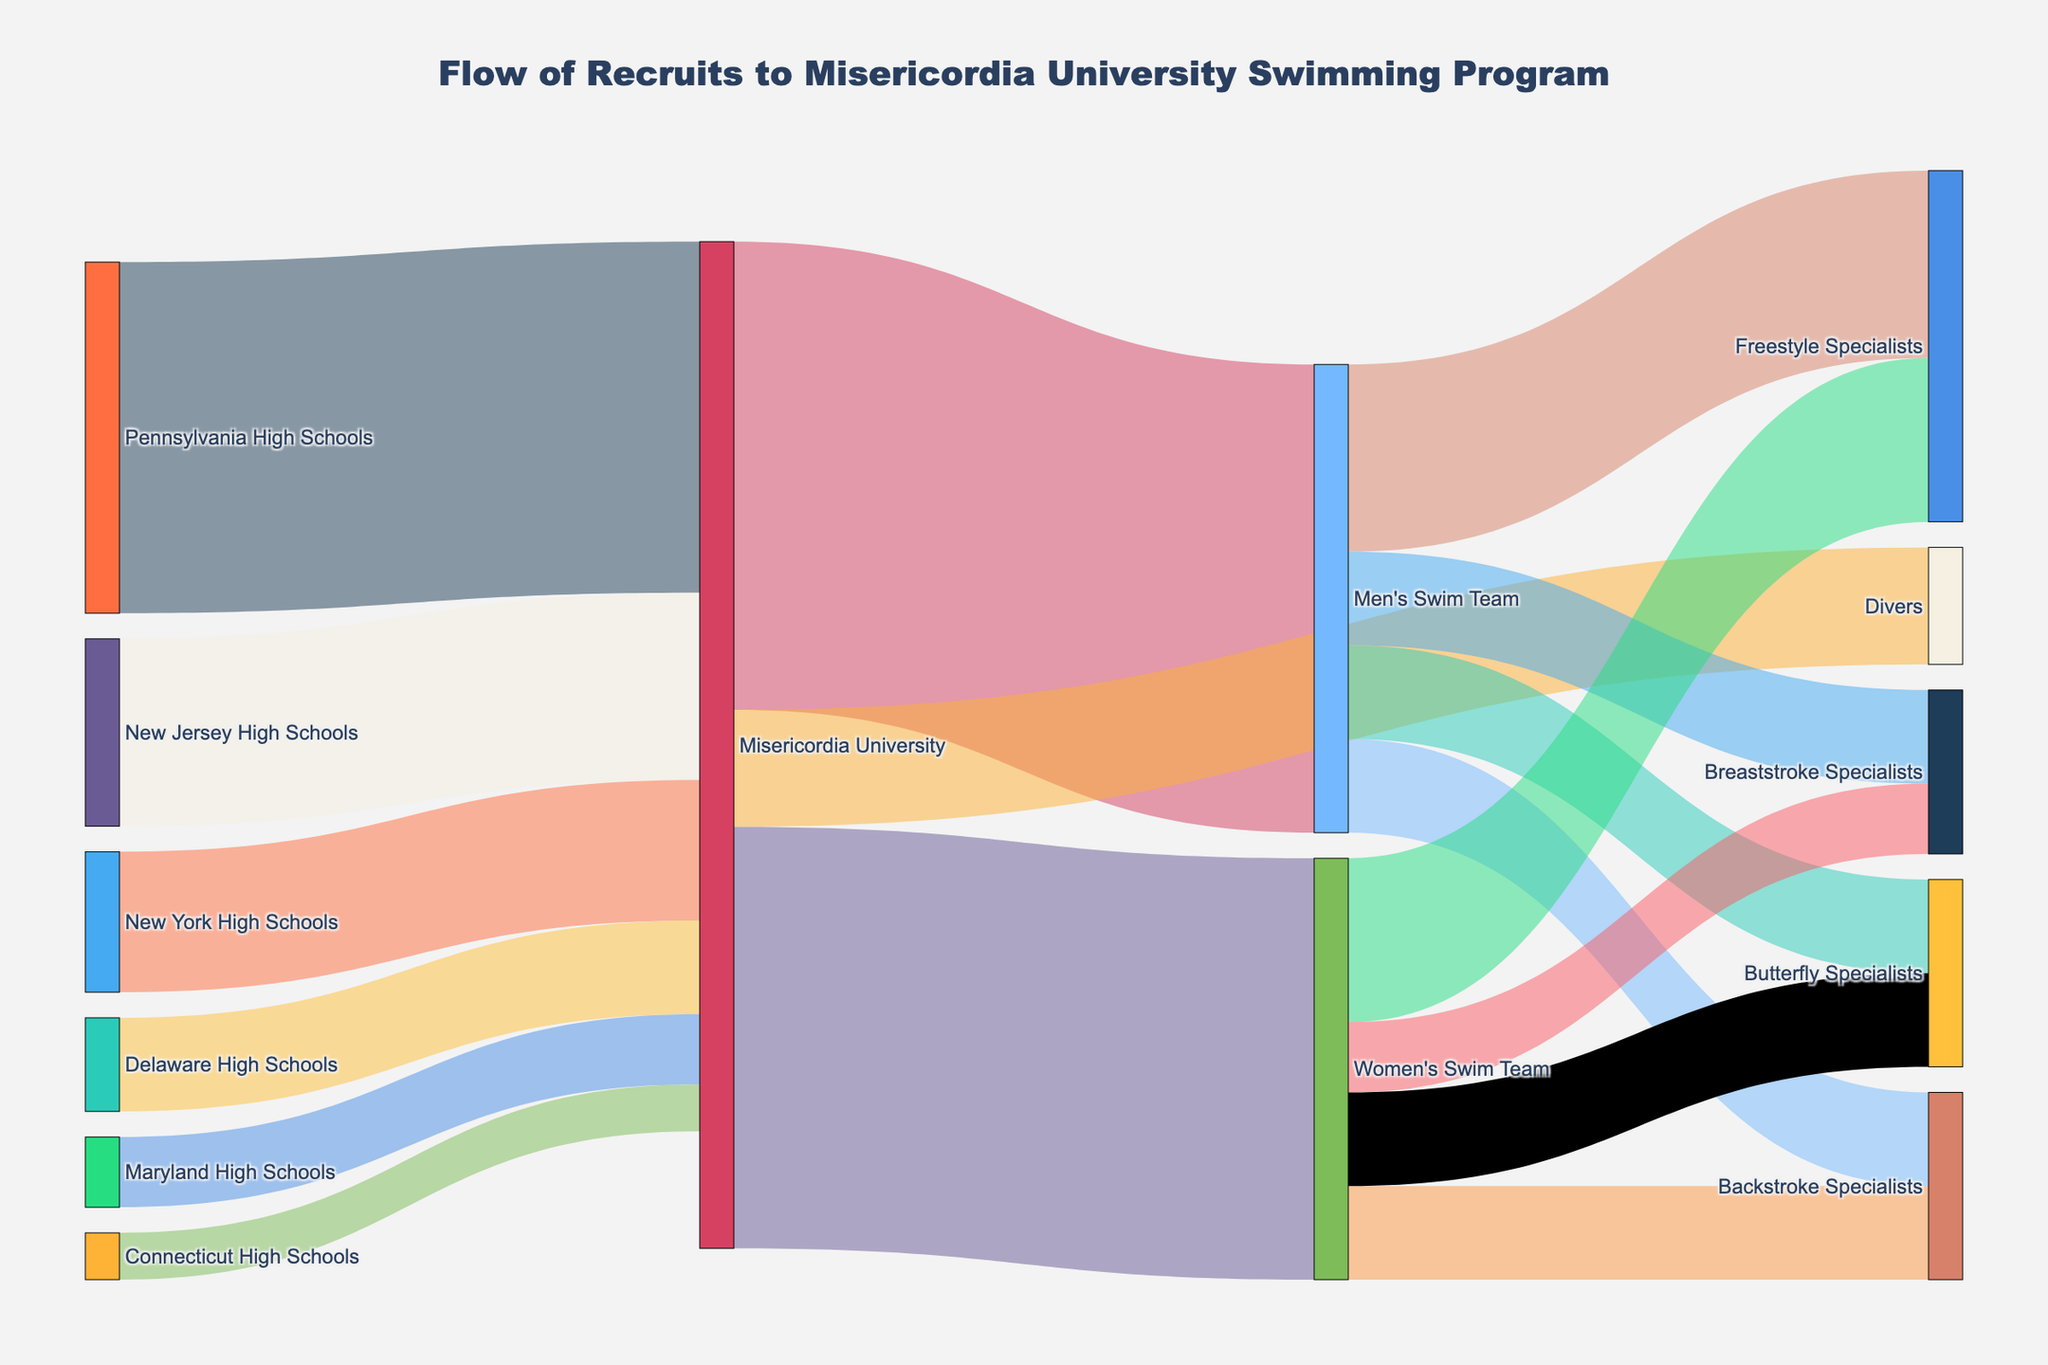How many recruits came from Pennsylvania High Schools to Misericordia University? The figure shows the flow from Pennsylvania High Schools to Misericordia University with an associated value of 15.
Answer: 15 What are the three states that sent the most recruits to Misericordia University? By examining the flow sizes, Pennsylvania (15), New Jersey (8), and New York (6) are the states with the highest values moving to Misericordia University.
Answer: Pennsylvania, New Jersey, New York What's the total number of recruits in the Misericordia University swimming program? The sum of the values flowing into Misericordia University is 38 (15 from Pennsylvania + 8 from New Jersey + 6 from New York + 4 from Delaware + 3 from Maryland + 2 from Connecticut).
Answer: 38 How many recruits joined the Men’s Swim Team, Women’s Swim Team, and Divers respectively? The value flows from Misericordia University to these teams show 20 for Men’s Swim Team, 18 for Women’s Swim Team, and 5 for Divers.
Answer: 20, 18, 5 Which specializations have the highest and the lowest number of recruits in the Men’s Swim Team? By looking at the flows from Men’s Swim Team, Freestyle Specialists have 8 recruits (highest), and the other specializations (Backstroke, Breaststroke, Butterfly) each have 4 recruits (lowest).
Answer: Freestyle Specialists (highest), Backstroke/Breaststroke/Butterfly Specialists (lowest) Which team, Men's or Women's, has more Freestyle Specialists? The flow shows 8 Freestyle Specialists in Men’s Swim Team and 7 in Women’s Swim Team, making the Men’s Swim Team have more Freestyle Specialists.
Answer: Men's Swim Team How many more Freestyle Specialists are there in the Men’s Swim Team compared to the Women’s Swim Team? There are 8 Freestyle Specialists in Men’s and 7 in Women’s, resulting in 8 - 7 = 1 more in the Men’s team.
Answer: 1 From which high school does the least number of recruits come to Misericordia University? The flow shows Connecticut High Schools sending just 2 recruits, which is the least.
Answer: Connecticut High Schools What is the total number of specialists (Freestyle, Backstroke, Breaststroke, Butterfly) in the Women’s Swim Team? Summing up the values shows Freestyle (7), Backstroke (4), Breaststroke (3), and Butterfly (4), making a total of 7 + 4 + 3 + 4 = 18.
Answer: 18 How is the distribution of recruits between Men's and Women's Swim Teams and Divers at Misericordia University? The flow indicates Men's Swim Team (20), Women's Swim Team (18), and Divers (5).
Answer: 20, 18, 5 